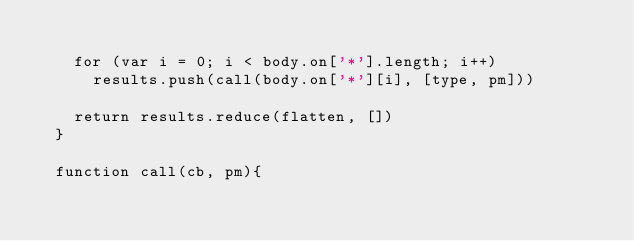Convert code to text. <code><loc_0><loc_0><loc_500><loc_500><_JavaScript_>
    for (var i = 0; i < body.on['*'].length; i++)
      results.push(call(body.on['*'][i], [type, pm]))

    return results.reduce(flatten, [])
  }

  function call(cb, pm){</code> 